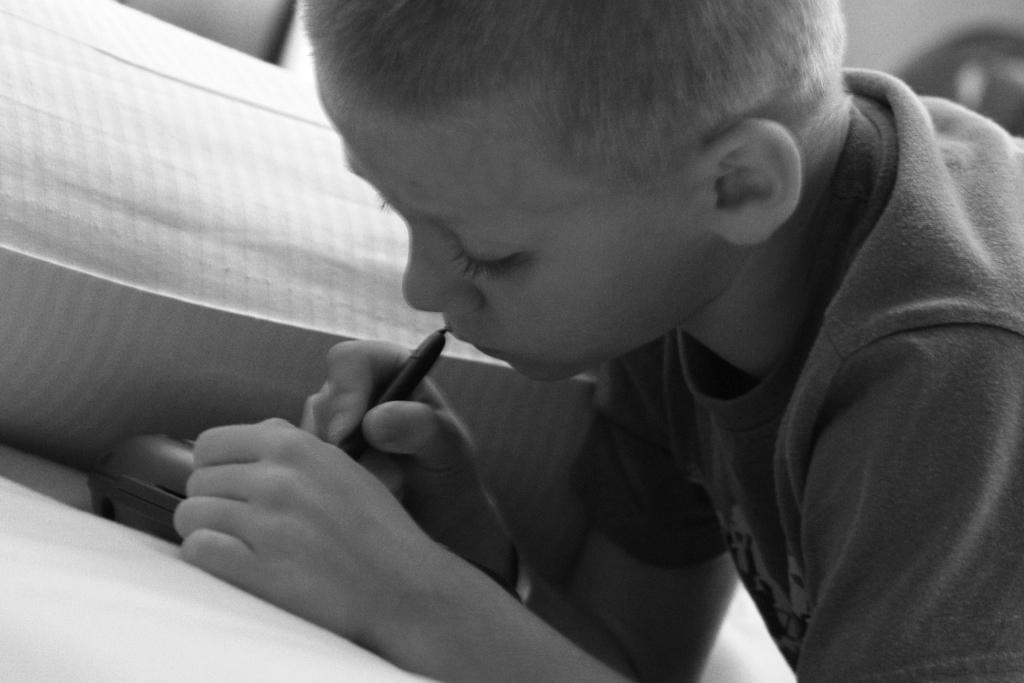What is the color scheme of the image? The image is black and white. Who is the main subject in the image? There is a boy in the image. What is the boy holding in the image? The boy is holding a pen. What is the boy doing with the pen? The boy is writing something on an object. How many trays can be seen in the image? There are no trays present in the image. What time of day is it in the image? The image does not provide any information about the time of day, as it is black and white and does not include any clocks or other time-related objects. 